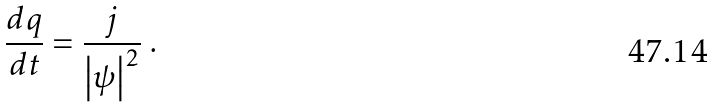<formula> <loc_0><loc_0><loc_500><loc_500>\frac { d q } { d t } = \frac { j } { \left | \psi \right | ^ { 2 } } \ .</formula> 